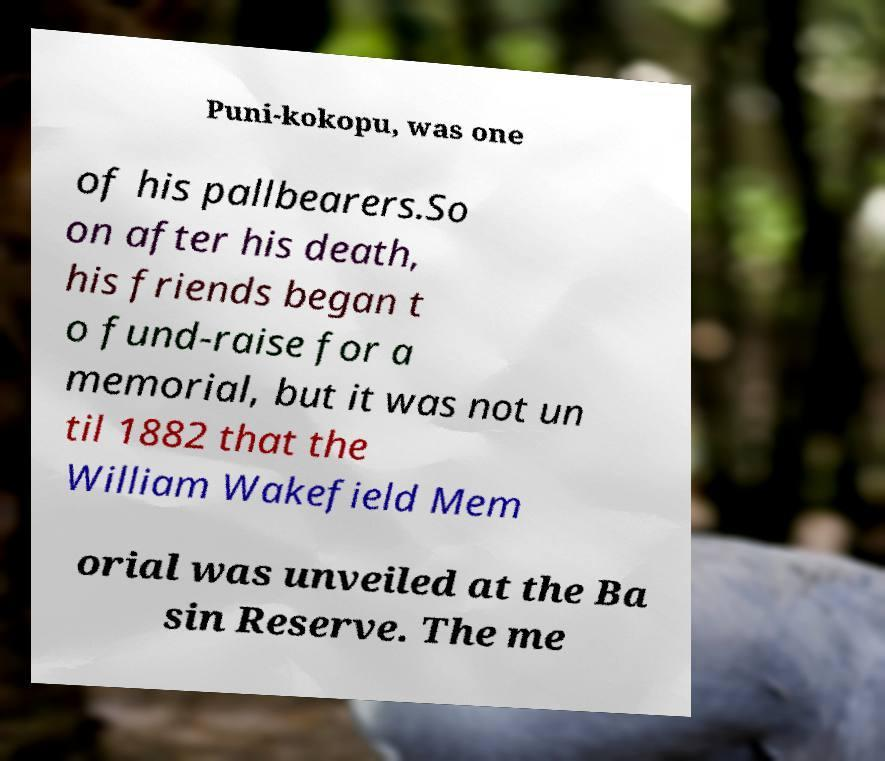Can you read and provide the text displayed in the image?This photo seems to have some interesting text. Can you extract and type it out for me? Puni-kokopu, was one of his pallbearers.So on after his death, his friends began t o fund-raise for a memorial, but it was not un til 1882 that the William Wakefield Mem orial was unveiled at the Ba sin Reserve. The me 